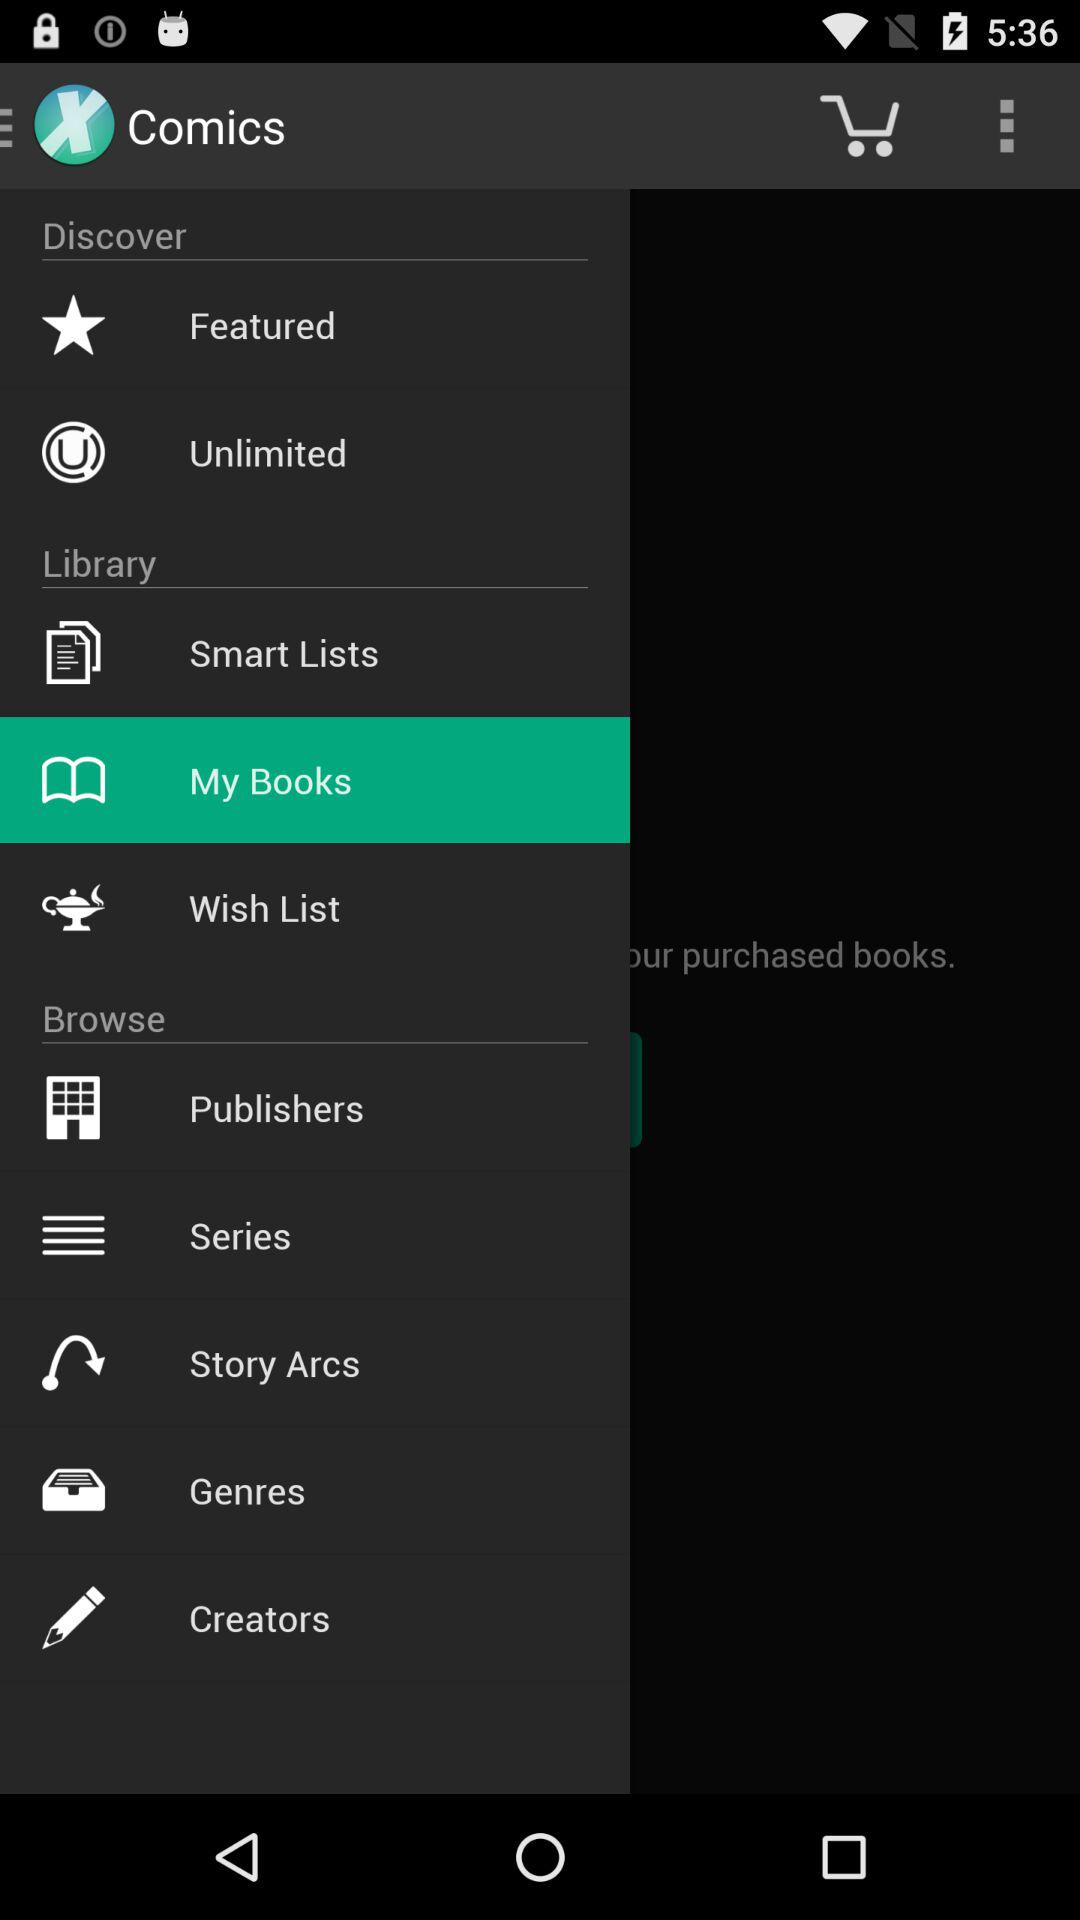How many items are on the wishlist?
When the provided information is insufficient, respond with <no answer>. <no answer> 